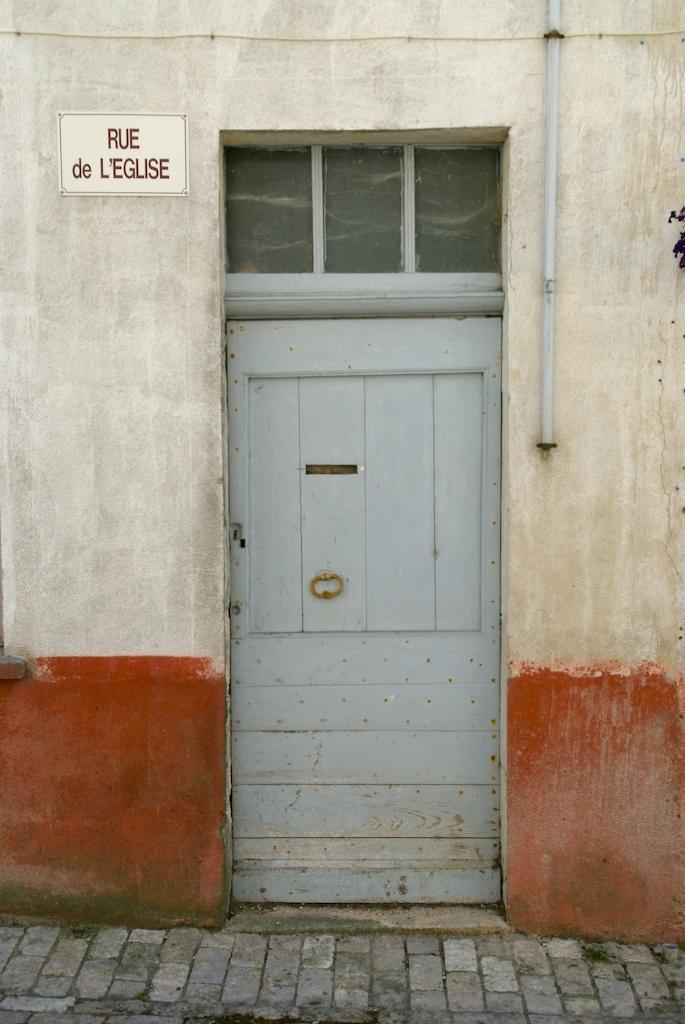What type of structure can be seen in the image? There is a wall in the image. What feature is present on the wall? There is a door on the wall. Can you describe the window in the image? There is a glass ventilator window present. What is written or displayed on a board in the image? There is a board with text in the image. What type of object is present in the image that might be used for transporting fluids? There is a pipe present in the image. What type of beds can be seen in the image? There are no beds present in the image. What type of learning is taking place in the image? There is no learning activity depicted in the image. 